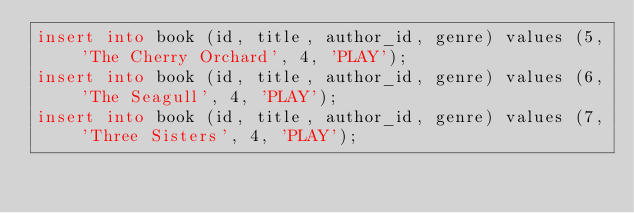<code> <loc_0><loc_0><loc_500><loc_500><_SQL_>insert into book (id, title, author_id, genre) values (5, 'The Cherry Orchard', 4, 'PLAY');
insert into book (id, title, author_id, genre) values (6, 'The Seagull', 4, 'PLAY');
insert into book (id, title, author_id, genre) values (7, 'Three Sisters', 4, 'PLAY');
</code> 